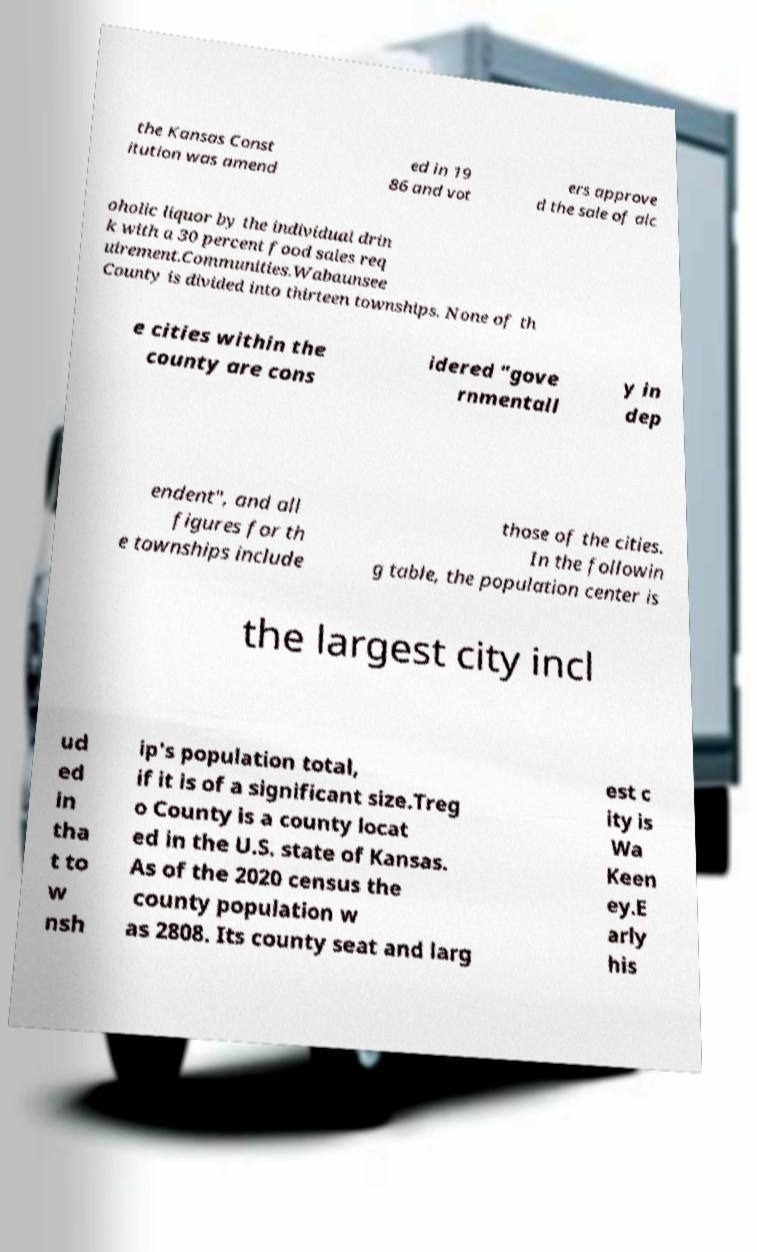Please identify and transcribe the text found in this image. the Kansas Const itution was amend ed in 19 86 and vot ers approve d the sale of alc oholic liquor by the individual drin k with a 30 percent food sales req uirement.Communities.Wabaunsee County is divided into thirteen townships. None of th e cities within the county are cons idered "gove rnmentall y in dep endent", and all figures for th e townships include those of the cities. In the followin g table, the population center is the largest city incl ud ed in tha t to w nsh ip's population total, if it is of a significant size.Treg o County is a county locat ed in the U.S. state of Kansas. As of the 2020 census the county population w as 2808. Its county seat and larg est c ity is Wa Keen ey.E arly his 